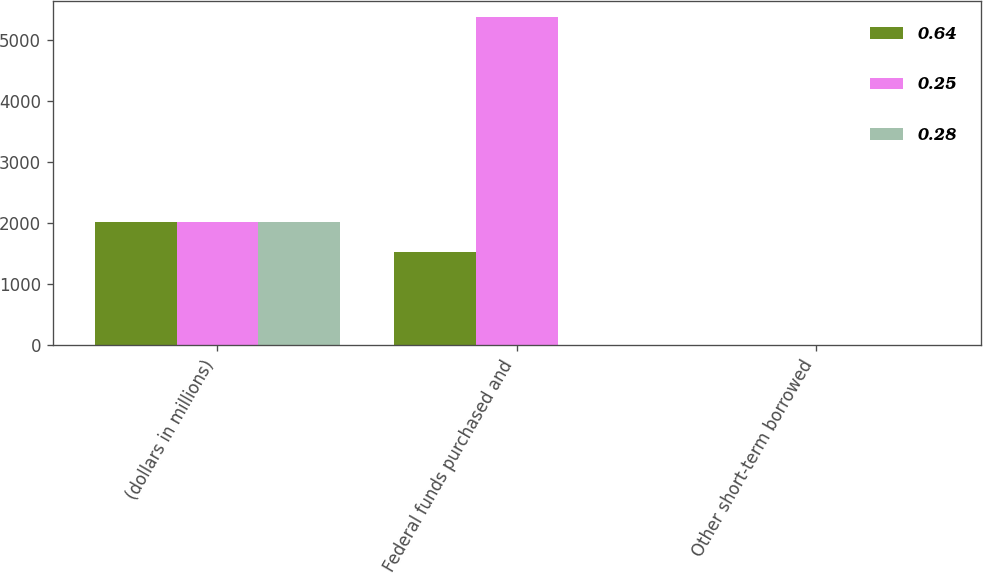Convert chart. <chart><loc_0><loc_0><loc_500><loc_500><stacked_bar_chart><ecel><fcel>(dollars in millions)<fcel>Federal funds purchased and<fcel>Other short-term borrowed<nl><fcel>0.64<fcel>2016<fcel>1522<fcel>0.94<nl><fcel>0.25<fcel>2015<fcel>5375<fcel>0.44<nl><fcel>0.28<fcel>2014<fcel>0.94<fcel>0.26<nl></chart> 